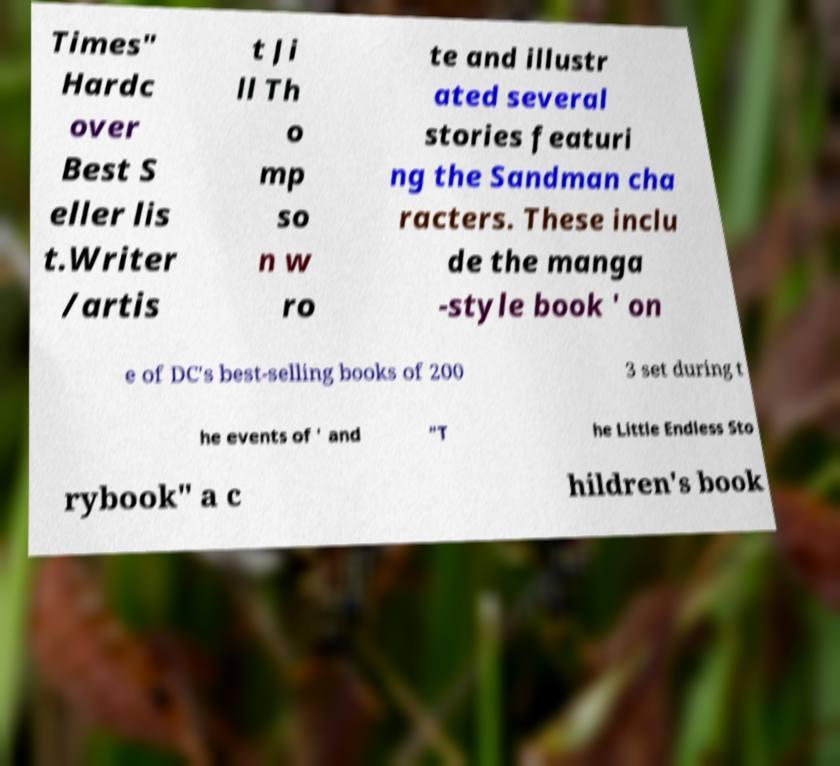Please read and relay the text visible in this image. What does it say? Times" Hardc over Best S eller lis t.Writer /artis t Ji ll Th o mp so n w ro te and illustr ated several stories featuri ng the Sandman cha racters. These inclu de the manga -style book ' on e of DC's best-selling books of 200 3 set during t he events of ' and "T he Little Endless Sto rybook" a c hildren's book 